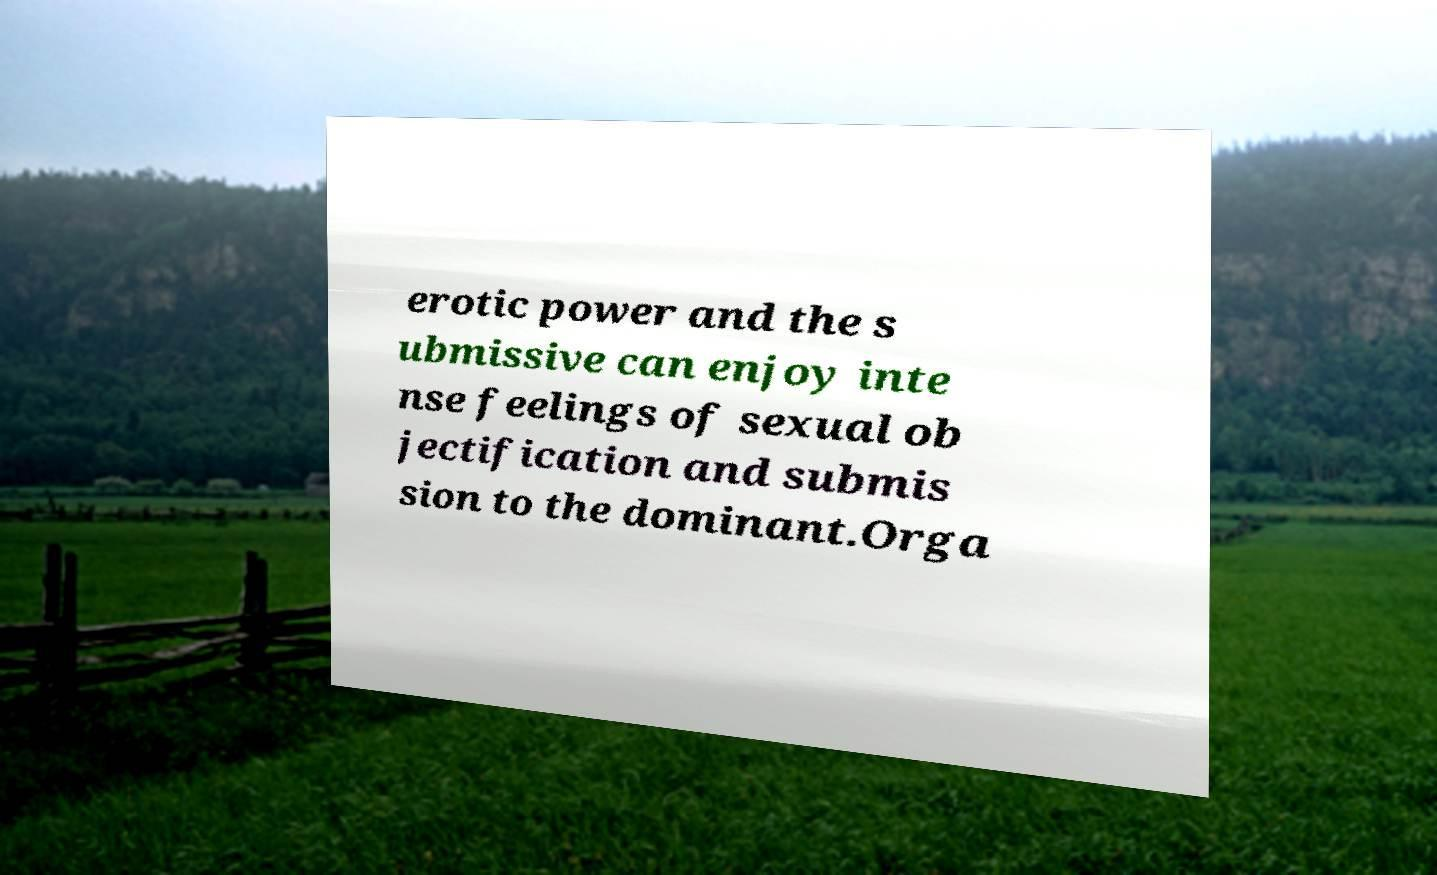For documentation purposes, I need the text within this image transcribed. Could you provide that? erotic power and the s ubmissive can enjoy inte nse feelings of sexual ob jectification and submis sion to the dominant.Orga 